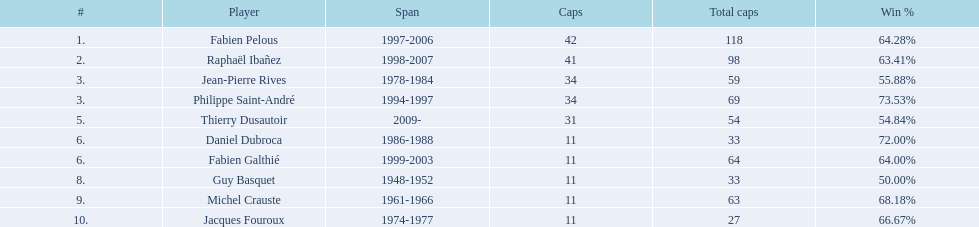Only player to serve as captain from 1998-2007 Raphaël Ibañez. 